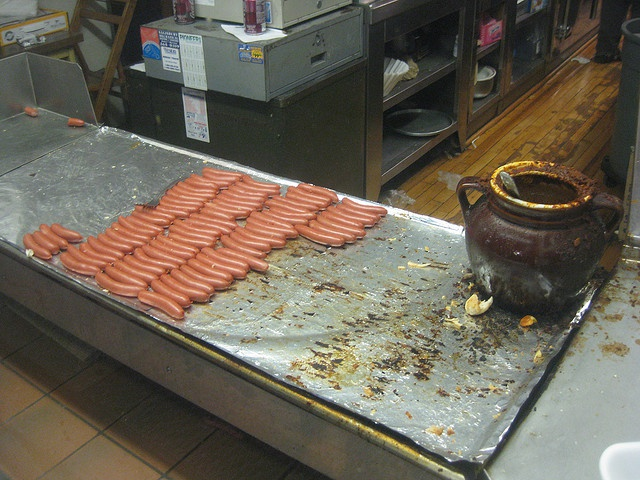Describe the objects in this image and their specific colors. I can see hot dog in gray, brown, salmon, and tan tones, hot dog in gray, brown, and salmon tones, hot dog in gray, brown, and salmon tones, hot dog in gray, brown, salmon, and tan tones, and hot dog in gray, brown, and salmon tones in this image. 